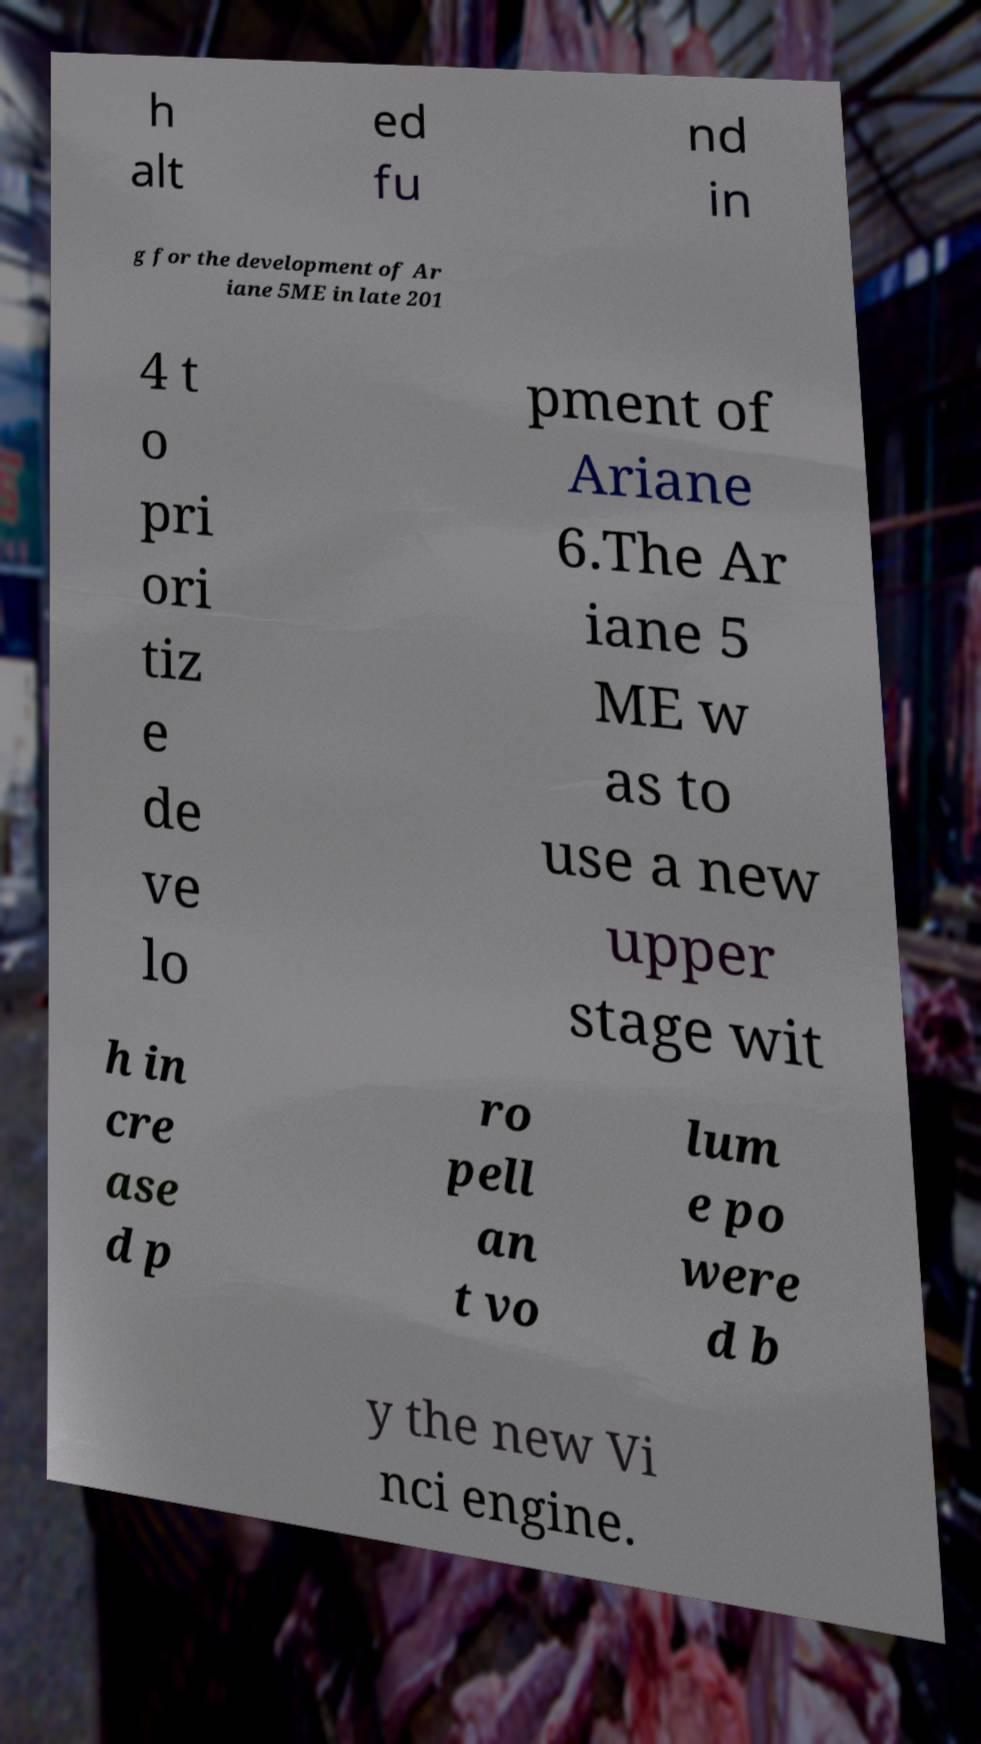Can you accurately transcribe the text from the provided image for me? h alt ed fu nd in g for the development of Ar iane 5ME in late 201 4 t o pri ori tiz e de ve lo pment of Ariane 6.The Ar iane 5 ME w as to use a new upper stage wit h in cre ase d p ro pell an t vo lum e po were d b y the new Vi nci engine. 